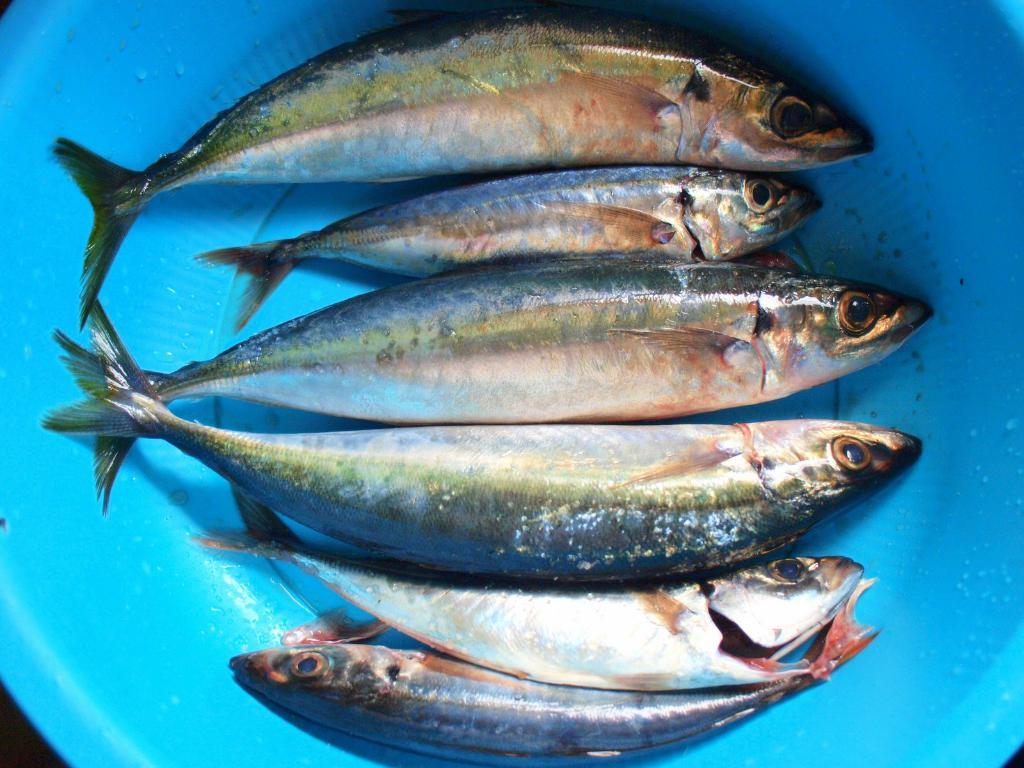How many fishes are present in the image? There are six fishes in the image. What is the color of the bowl containing the fishes? The fishes are in a blue color bowl. What type of apparatus is used for the distribution of fishes in the image? There is no apparatus for the distribution of fishes in the image; the fishes are already in the bowl. In which country is the image taken? The provided facts do not mention the country where the image was taken, so it cannot be determined from the information given. 